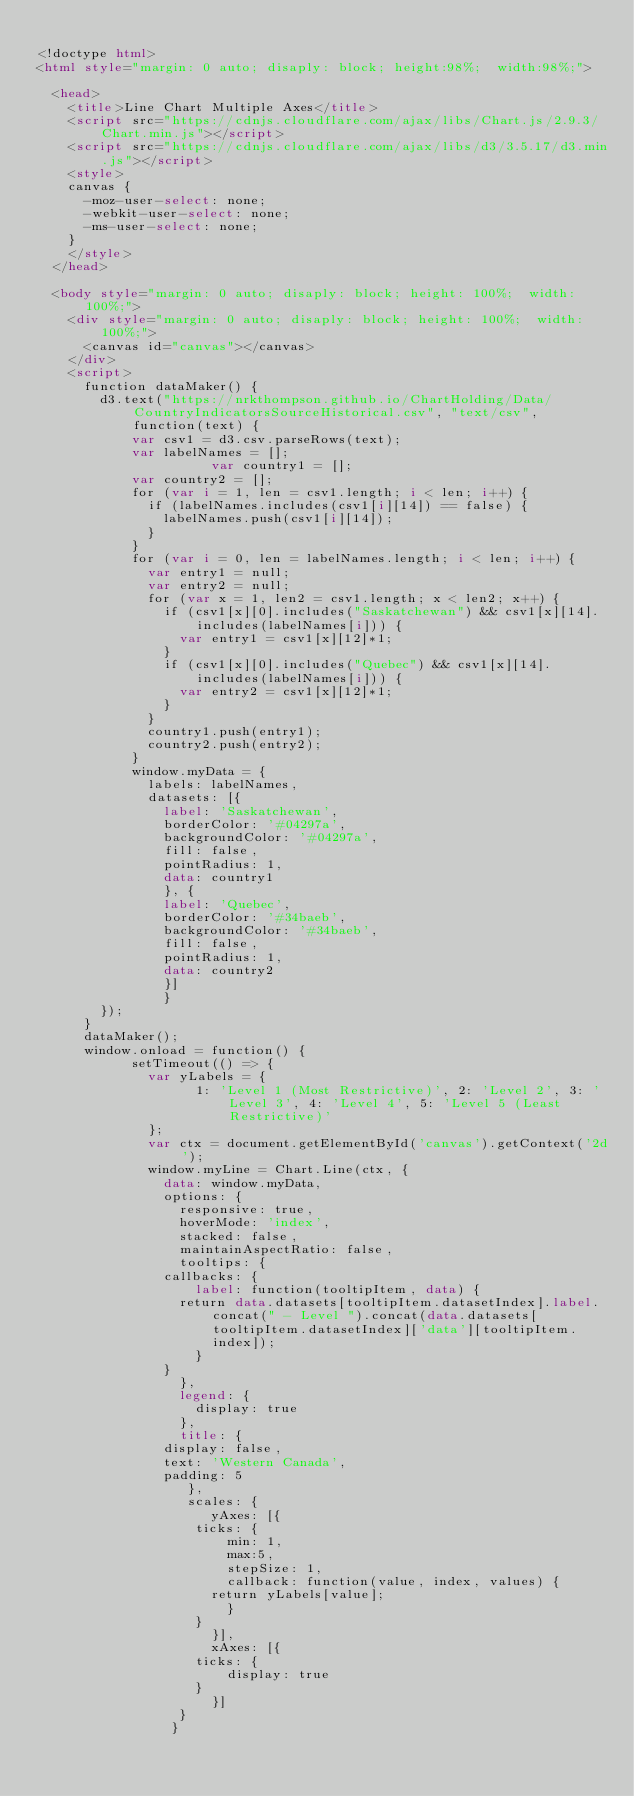Convert code to text. <code><loc_0><loc_0><loc_500><loc_500><_HTML_>
<!doctype html>
<html style="margin: 0 auto; disaply: block; height:98%;  width:98%;">

	<head>
		<title>Line Chart Multiple Axes</title>
		<script src="https://cdnjs.cloudflare.com/ajax/libs/Chart.js/2.9.3/Chart.min.js"></script>
		<script src="https://cdnjs.cloudflare.com/ajax/libs/d3/3.5.17/d3.min.js"></script>
		<style>
		canvas {
			-moz-user-select: none;
			-webkit-user-select: none;
			-ms-user-select: none;
		}
		</style>
	</head>

	<body style="margin: 0 auto; disaply: block; height: 100%;  width: 100%;">
		<div style="margin: 0 auto; disaply: block; height: 100%;  width: 100%;">
			<canvas id="canvas"></canvas>
		</div>
		<script>
			function dataMaker() {
				d3.text("https://nrkthompson.github.io/ChartHolding/Data/CountryIndicatorsSourceHistorical.csv", "text/csv", function(text) {
					  var csv1 = d3.csv.parseRows(text);
					  var labelNames = [];
            				  var country1 = [];
					  var country2 = [];
					  for (var i = 1, len = csv1.length; i < len; i++) {
						  if (labelNames.includes(csv1[i][14]) == false) {
							  labelNames.push(csv1[i][14]);
						  }
					  }
					  for (var i = 0, len = labelNames.length; i < len; i++) {
						  var entry1 = null;
						  var entry2 = null;
						  for (var x = 1, len2 = csv1.length; x < len2; x++) {
							  if (csv1[x][0].includes("Saskatchewan") && csv1[x][14].includes(labelNames[i])) {
								  var entry1 = csv1[x][12]*1;
							  }
							  if (csv1[x][0].includes("Quebec") && csv1[x][14].includes(labelNames[i])) {
								  var entry2 = csv1[x][12]*1;
							  }
						  }
						  country1.push(entry1);
						  country2.push(entry2);
					  }
					  window.myData = {
						  labels: labelNames,
						  datasets: [{
						    label: 'Saskatchewan',
						    borderColor: '#04297a',
						    backgroundColor: '#04297a',
						    fill: false,
						    pointRadius: 1,
						    data: country1
						    }, {
						    label: 'Quebec',
						    borderColor: '#34baeb',
						    backgroundColor: '#34baeb',
						    fill: false,
						    pointRadius: 1,
						    data: country2
						    }]
						    }  
				});
			}
			dataMaker();
			window.onload = function() {
						setTimeout(() => { 
							var yLabels = {
							      1: 'Level 1 (Most Restrictive)', 2: 'Level 2', 3: 'Level 3', 4: 'Level 4', 5: 'Level 5 (Least Restrictive)'
							};
							var ctx = document.getElementById('canvas').getContext('2d');
							window.myLine = Chart.Line(ctx, {
							  data: window.myData,
							  options: {
							    responsive: true,
							    hoverMode: 'index',
							    stacked: false,
							    maintainAspectRatio: false,
							    tooltips: {
								callbacks: {
								    label: function(tooltipItem, data) {
									return data.datasets[tooltipItem.datasetIndex].label.concat(" - Level ").concat(data.datasets[tooltipItem.datasetIndex]['data'][tooltipItem.index]);
								    }
								}
							    },
							    legend: {
								    display: true
							    },
							    title: {
								display: false,
								text: 'Western Canada',
								padding: 5
							     },
							     scales: {
								      yAxes: [{
									  ticks: {
									      min: 1,
									      max:5,
									      stepSize: 1,
									      callback: function(value, index, values) {
										  return yLabels[value];
									      }
									  }
								      }],
								      xAxes: [{
									  ticks: {
									      display: true
									  }
								      }]
								  }
							   }</code> 